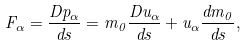Convert formula to latex. <formula><loc_0><loc_0><loc_500><loc_500>F _ { \alpha } = \frac { D p _ { \alpha } } { d s } = m _ { 0 } \frac { D u _ { \alpha } } { d s } + u _ { \alpha } \frac { d m _ { 0 } } { d s } ,</formula> 